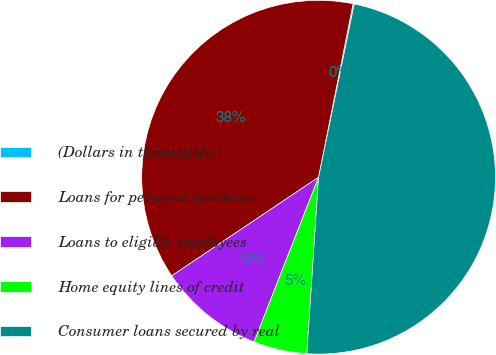<chart> <loc_0><loc_0><loc_500><loc_500><pie_chart><fcel>(Dollars in thousands)<fcel>Loans for personal residence<fcel>Loans to eligible employees<fcel>Home equity lines of credit<fcel>Consumer loans secured by real<nl><fcel>0.11%<fcel>37.53%<fcel>9.65%<fcel>4.88%<fcel>47.82%<nl></chart> 